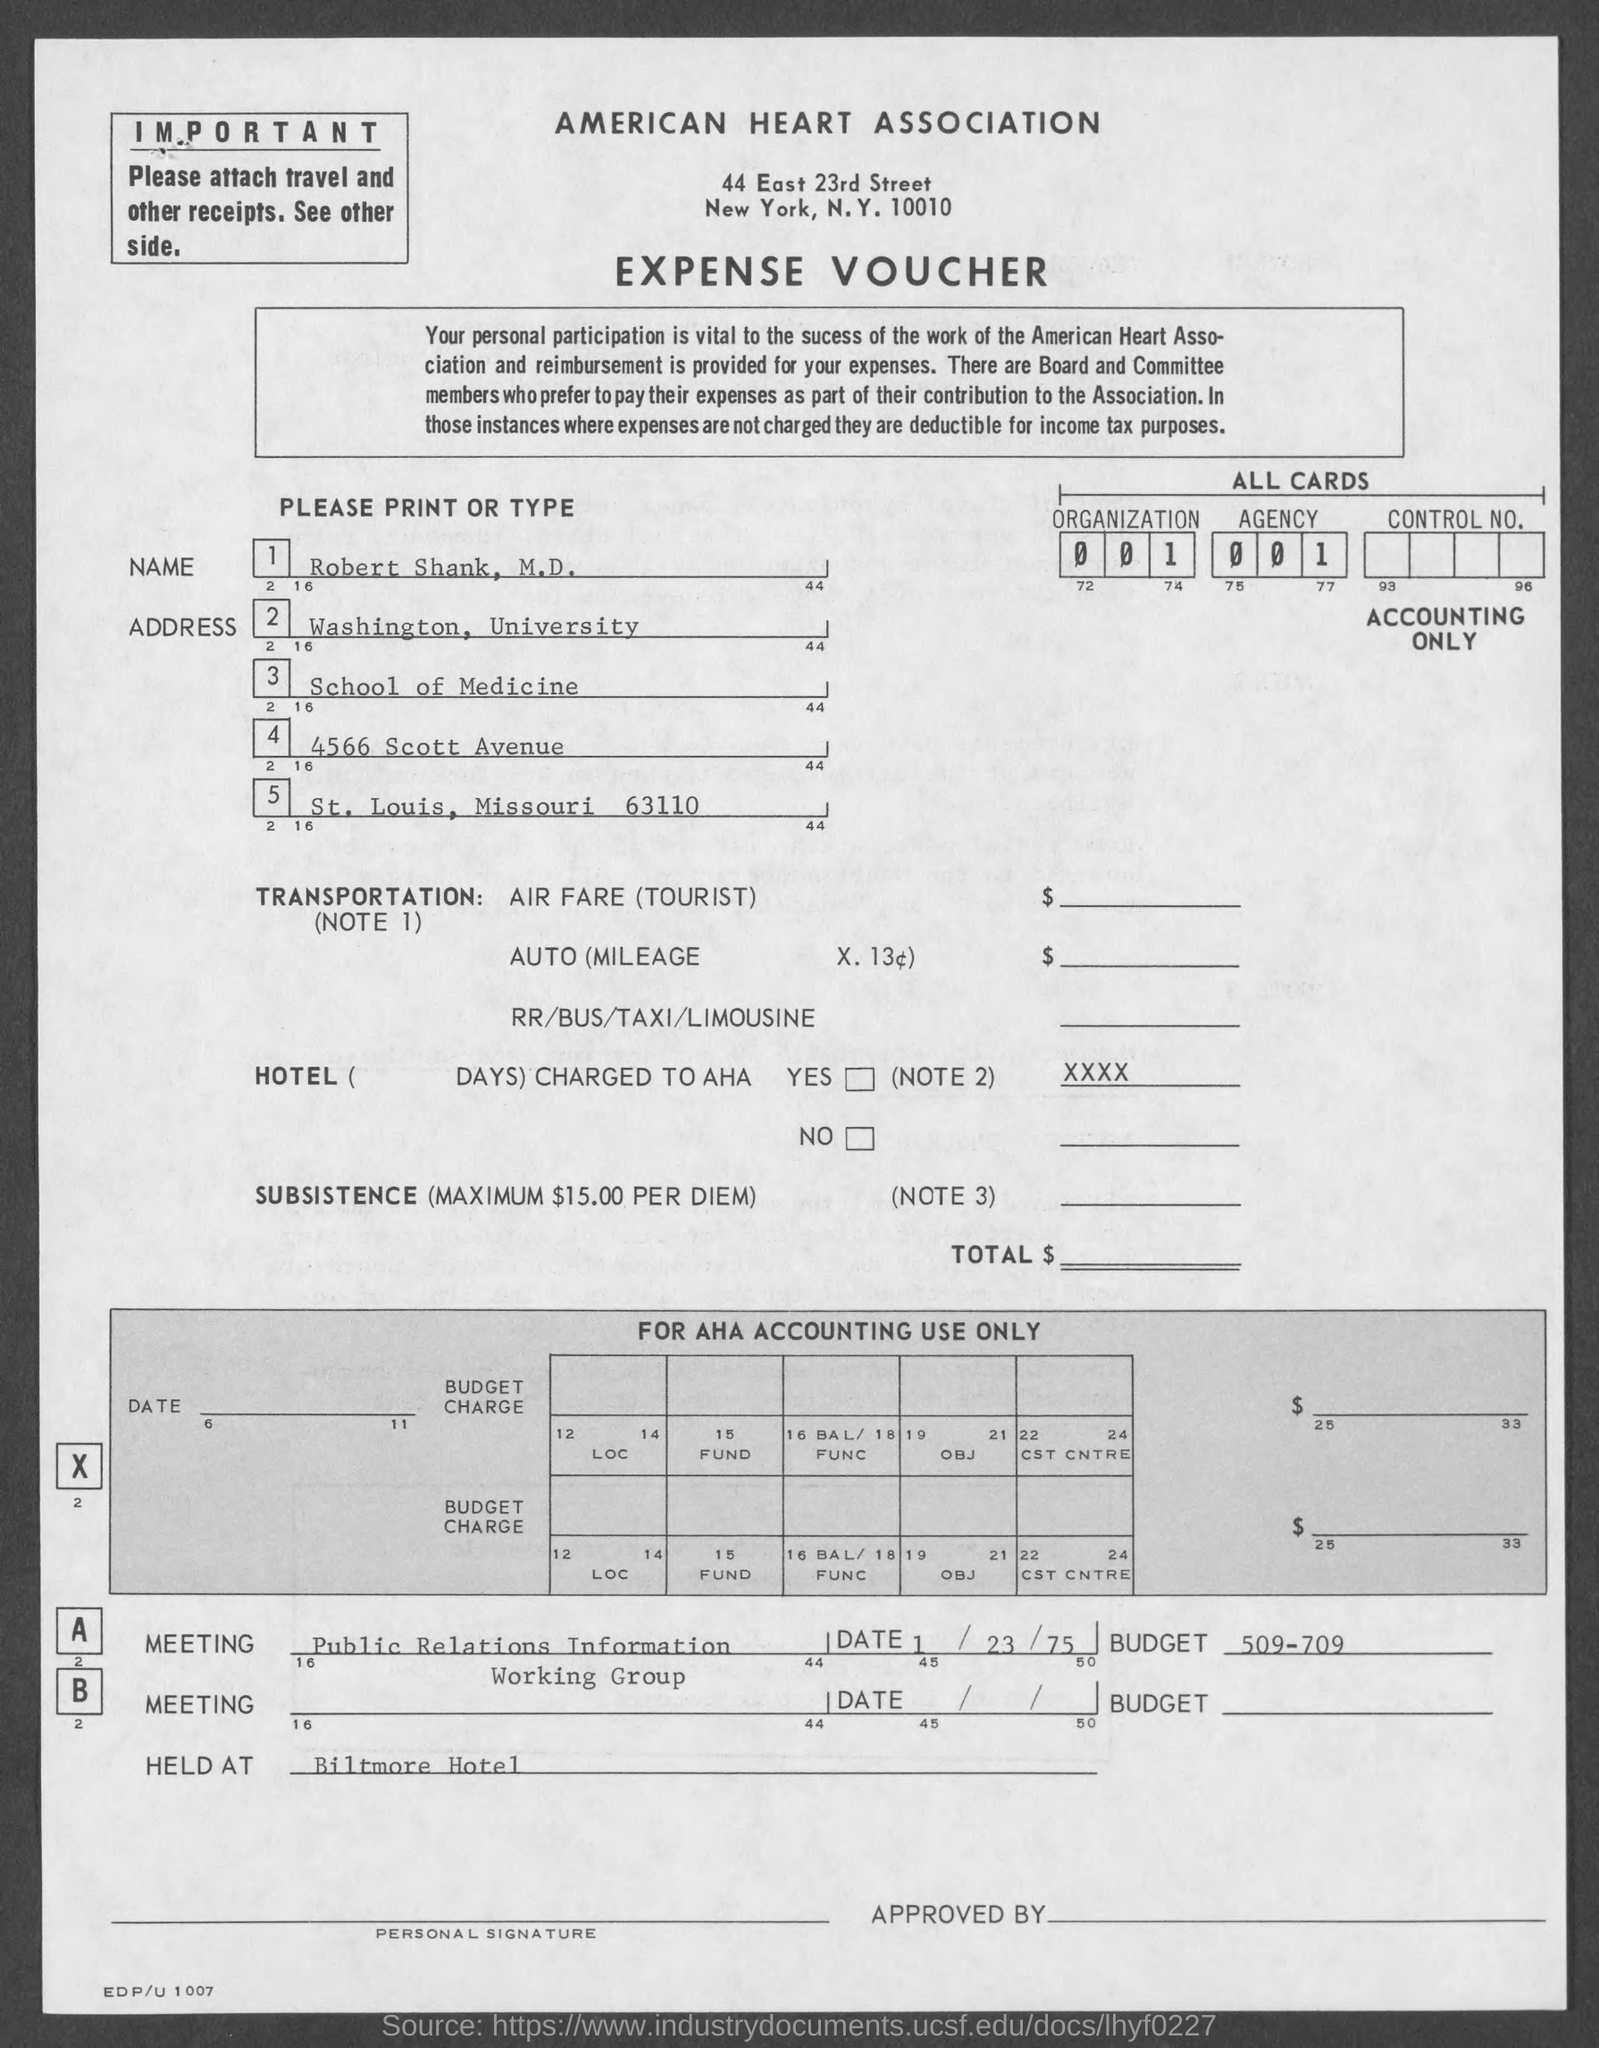What is the maximum per diem for subsistence mentioned? The maximum per diem for subsistence as mentioned on the expense voucher is $15.00.  Is there any indication who approved this voucher? There is a section labeled 'APPROVED BY' at the bottom right of the voucher, but the approver's name is not visible in the image provided. 